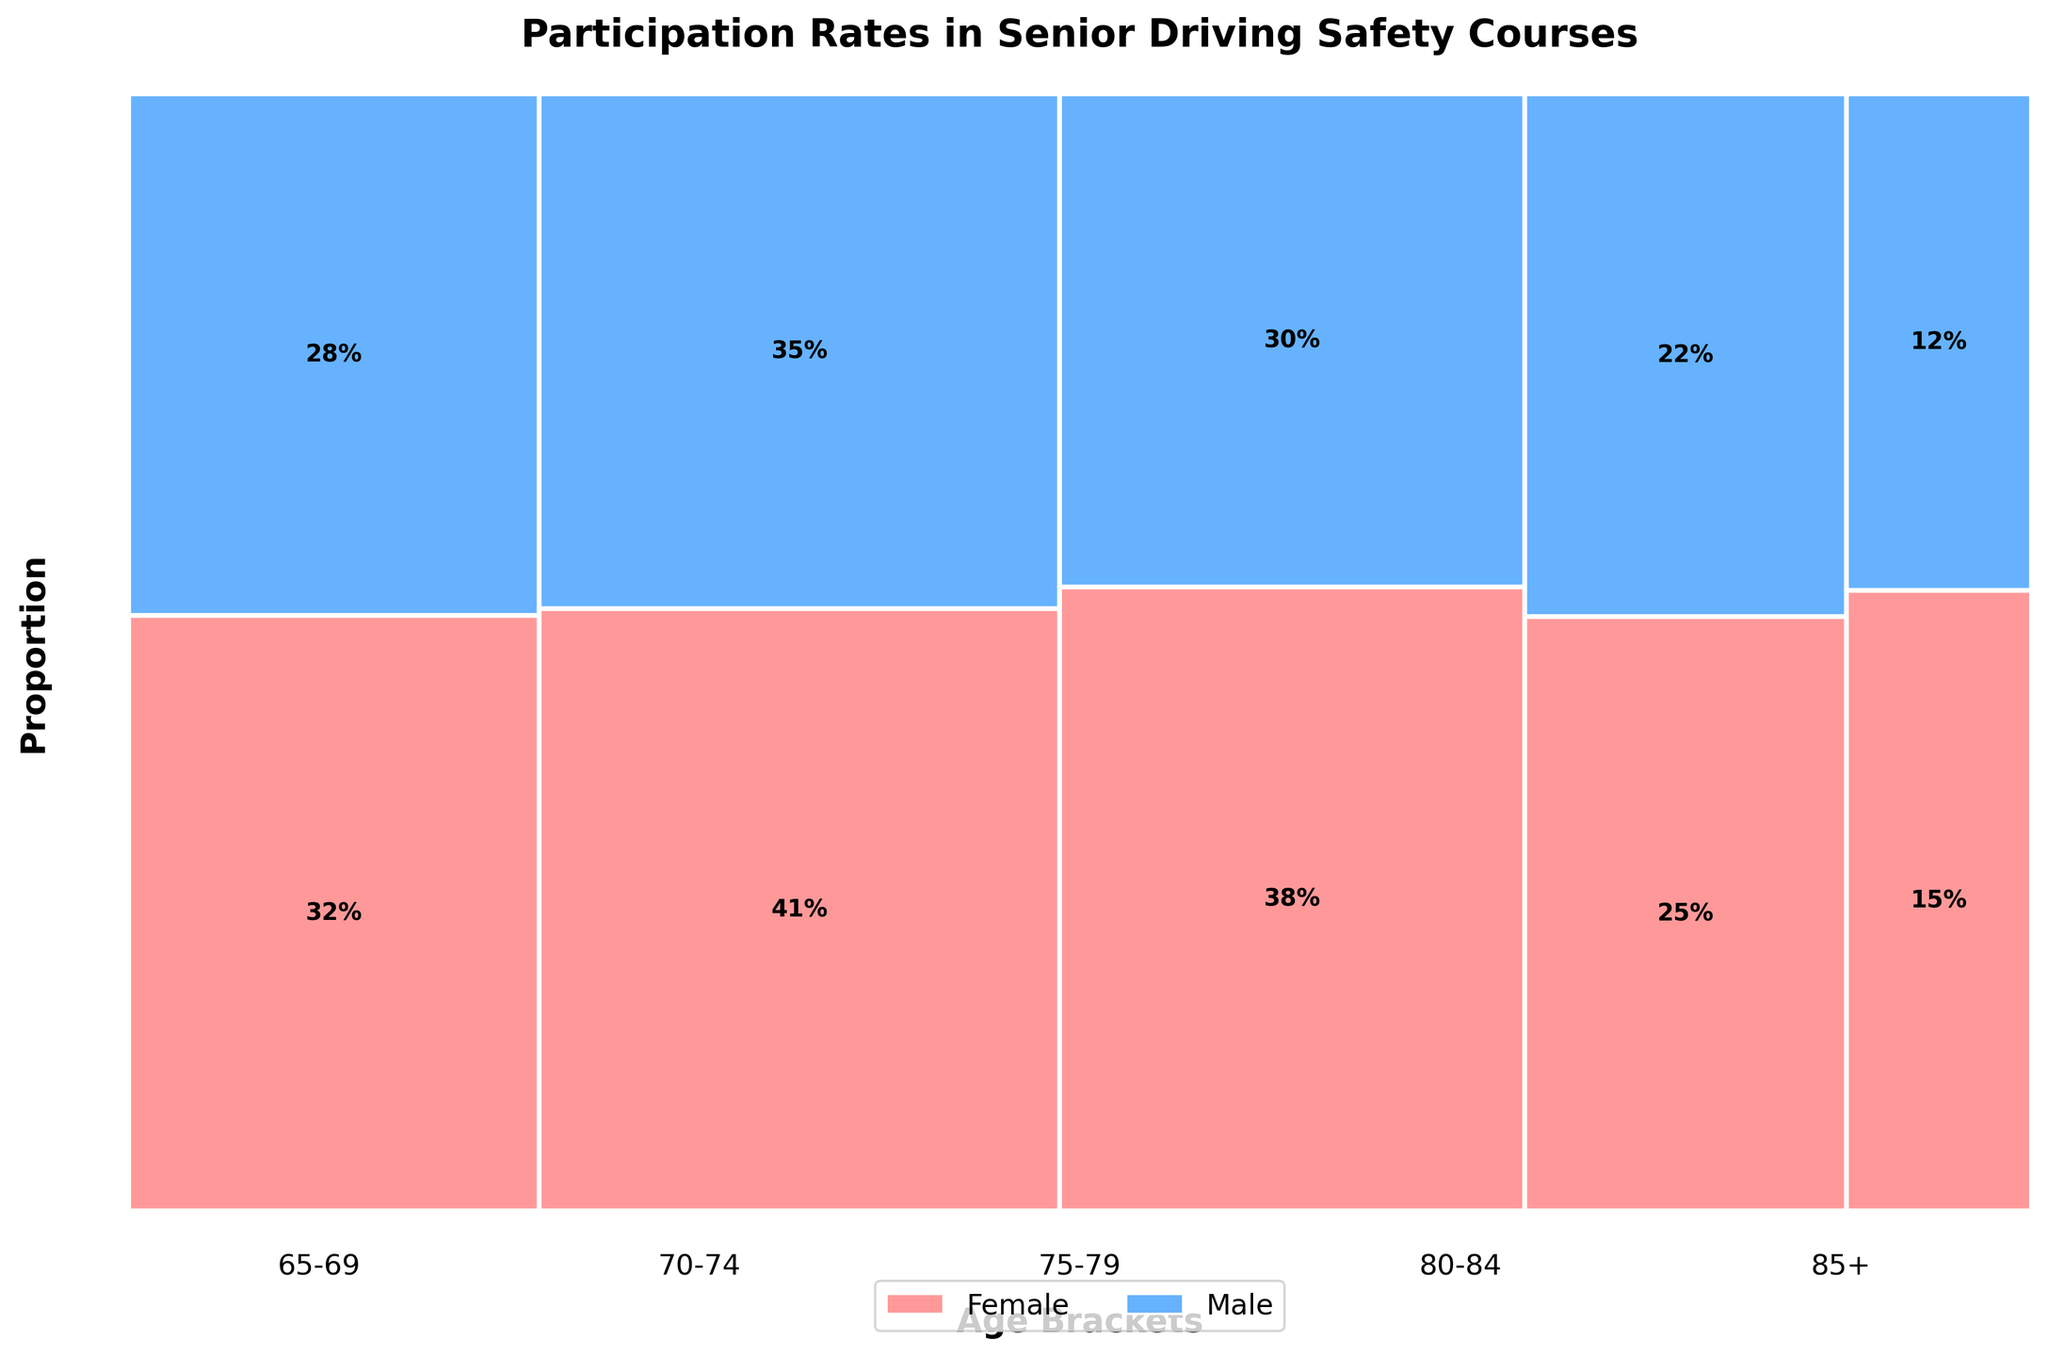What is the title of the plot? The title of a plot is often displayed at the top of the figure. In this case, the title "Participation Rates in Senior Driving Safety Courses" can be seen clearly above the mosaic plot.
Answer: Participation Rates in Senior Driving Safety Courses Which age bracket has the highest total participation rate? By looking at the widths of the bars for each age bracket, which represent the total participation rates, the 70-74 age bracket has the widest bar, indicating the highest total participation rate.
Answer: 70-74 What is the participation rate for males in the 80-84 age bracket? The figure shows the participation rates as percentages within each section of the bars. For the 80-84 age bracket, the male participation rate is labeled as 22%.
Answer: 22% How does the participation rate for females in the 75-79 age bracket compare to that in the 85+ age bracket? We can compare the labels directly. The female participation rate is 38% for the 75-79 age bracket and 15% for the 85+ age bracket, indicating a higher participation rate among females in the 75-79 age bracket.
Answer: Higher Are there more males or females participating in the 70-74 age bracket? The plot shows the participation rates for both males and females in the 70-74 age bracket. With 41% for females and 35% for males, more females are participating in this age bracket.
Answer: Females What is the total participation rate for the age bracket 65-69? The total participation rate for each age bracket is represented by the width of the bars. Adding the participation rates for males and females in the 65-69 age bracket, we get 32% + 28% = 60%.
Answer: 60% Which gender has a higher participation rate in the 85+ age bracket? By examining the plot's labels, females have a participation rate of 15%, while males have a participation rate of 12%, indicating a higher participation rate for females in the 85+ age bracket.
Answer: Females If you sum the participation rates for females across all age brackets, what is the total? To find the total participation rate for females across all age brackets, sum the individual participation rates: 32% + 41% + 38% + 25% + 15% = 151%.
Answer: 151% What is the total participation rate for males in the 75-79 and 80-84 age brackets combined? Sum the male participation rates for the 75-79 and 80-84 age brackets: 30% + 22% = 52%.
Answer: 52% Is there an age bracket where female participation is more than double the male participation rate? Comparing each age bracket, we notice that in the 85+ age bracket, the female participation rate (15%) is more than double the male participation rate (12%), hence not more than double. There is no age bracket that meets this criterion.
Answer: No 